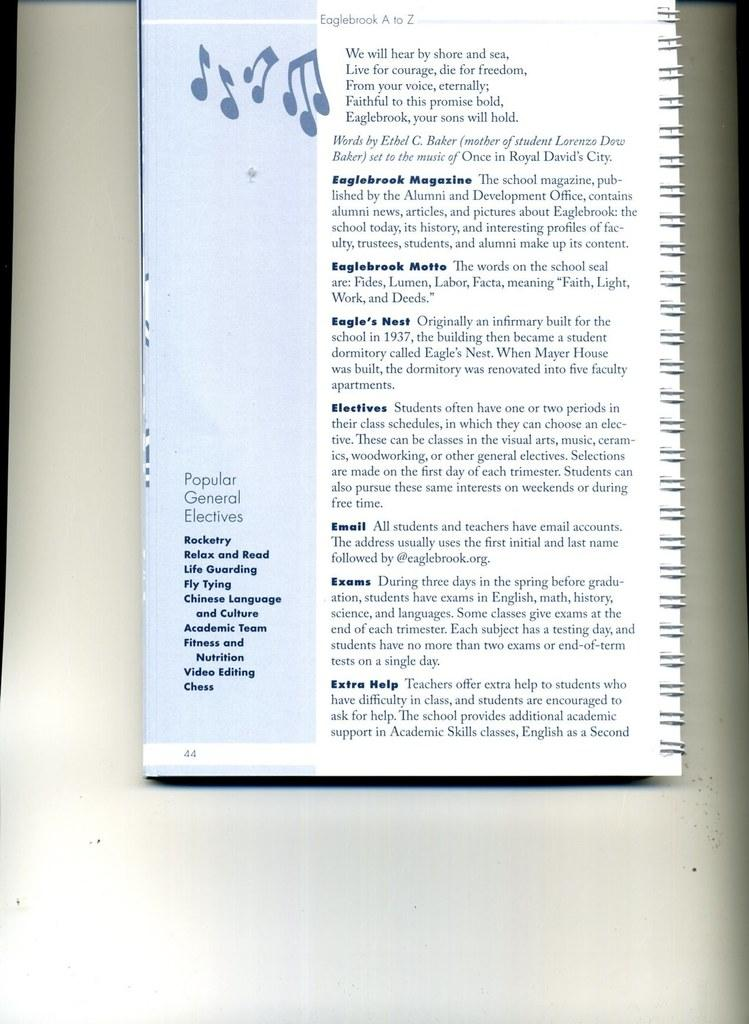<image>
Offer a succinct explanation of the picture presented. A ringed white handbook with blue text of Eaglebrook A to Z. 